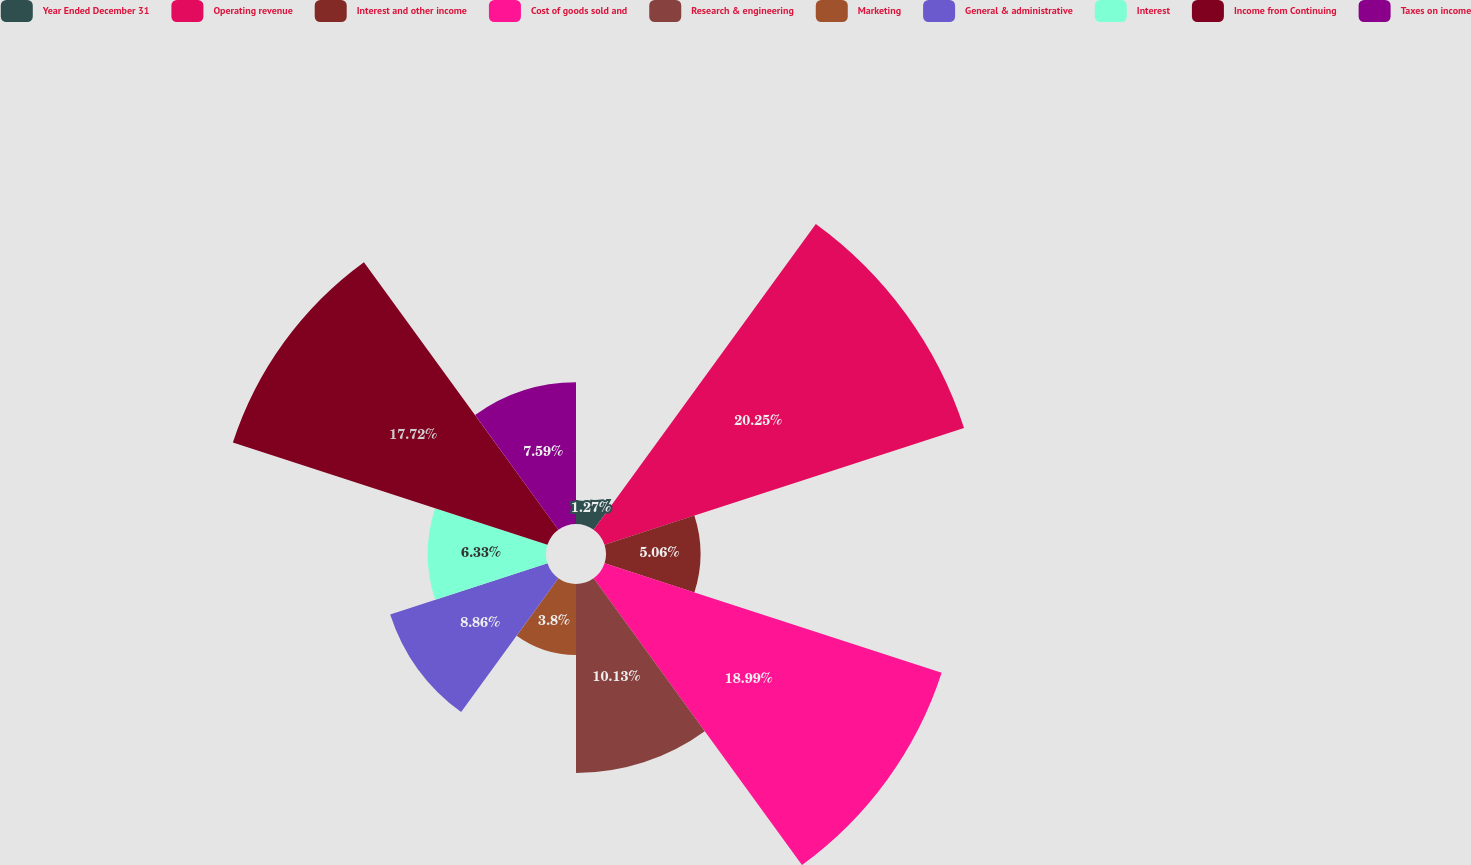Convert chart to OTSL. <chart><loc_0><loc_0><loc_500><loc_500><pie_chart><fcel>Year Ended December 31<fcel>Operating revenue<fcel>Interest and other income<fcel>Cost of goods sold and<fcel>Research & engineering<fcel>Marketing<fcel>General & administrative<fcel>Interest<fcel>Income from Continuing<fcel>Taxes on income<nl><fcel>1.27%<fcel>20.25%<fcel>5.06%<fcel>18.99%<fcel>10.13%<fcel>3.8%<fcel>8.86%<fcel>6.33%<fcel>17.72%<fcel>7.59%<nl></chart> 